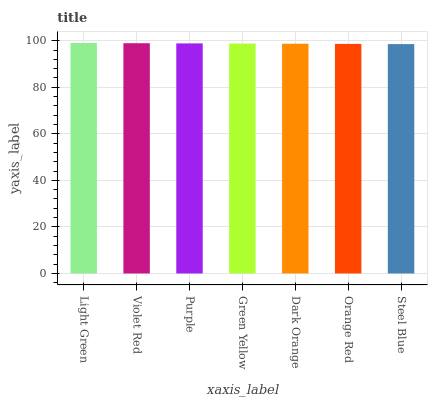Is Violet Red the minimum?
Answer yes or no. No. Is Violet Red the maximum?
Answer yes or no. No. Is Light Green greater than Violet Red?
Answer yes or no. Yes. Is Violet Red less than Light Green?
Answer yes or no. Yes. Is Violet Red greater than Light Green?
Answer yes or no. No. Is Light Green less than Violet Red?
Answer yes or no. No. Is Green Yellow the high median?
Answer yes or no. Yes. Is Green Yellow the low median?
Answer yes or no. Yes. Is Violet Red the high median?
Answer yes or no. No. Is Light Green the low median?
Answer yes or no. No. 